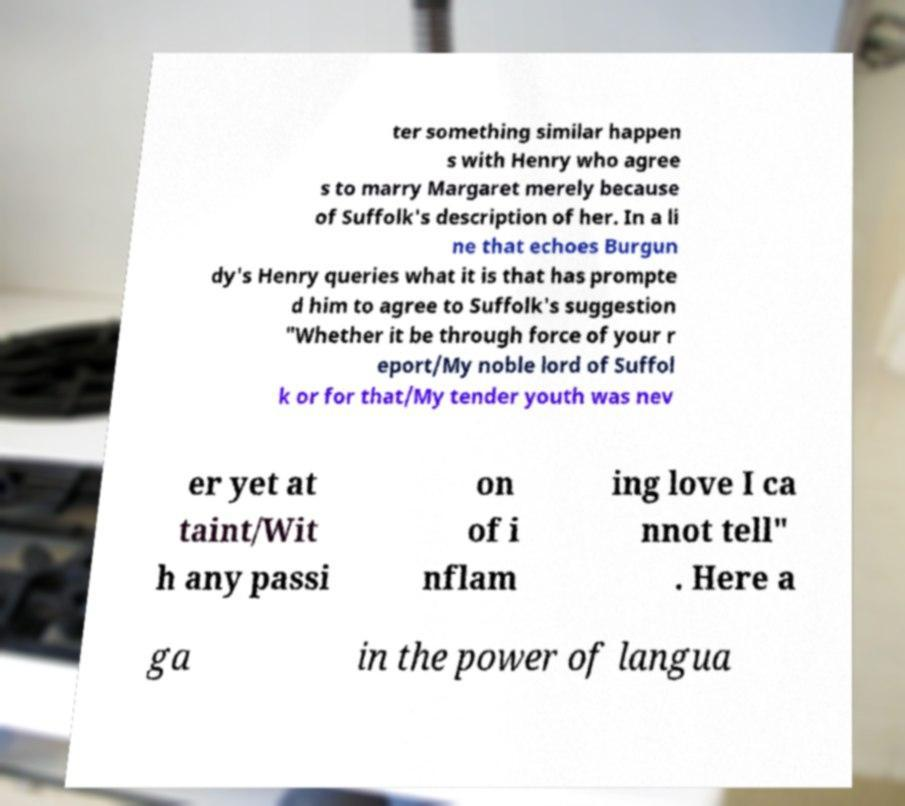Please identify and transcribe the text found in this image. ter something similar happen s with Henry who agree s to marry Margaret merely because of Suffolk's description of her. In a li ne that echoes Burgun dy's Henry queries what it is that has prompte d him to agree to Suffolk's suggestion "Whether it be through force of your r eport/My noble lord of Suffol k or for that/My tender youth was nev er yet at taint/Wit h any passi on of i nflam ing love I ca nnot tell" . Here a ga in the power of langua 